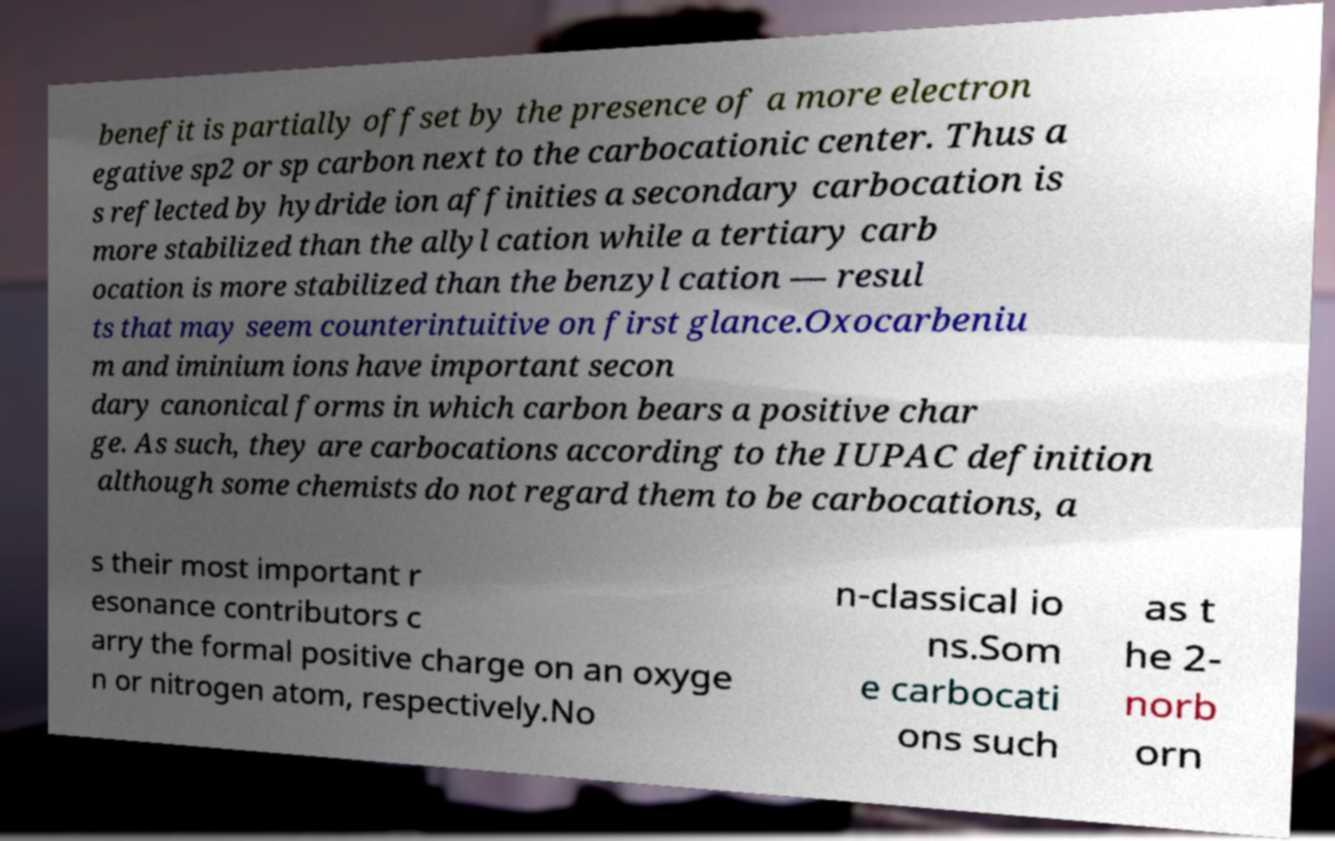I need the written content from this picture converted into text. Can you do that? benefit is partially offset by the presence of a more electron egative sp2 or sp carbon next to the carbocationic center. Thus a s reflected by hydride ion affinities a secondary carbocation is more stabilized than the allyl cation while a tertiary carb ocation is more stabilized than the benzyl cation — resul ts that may seem counterintuitive on first glance.Oxocarbeniu m and iminium ions have important secon dary canonical forms in which carbon bears a positive char ge. As such, they are carbocations according to the IUPAC definition although some chemists do not regard them to be carbocations, a s their most important r esonance contributors c arry the formal positive charge on an oxyge n or nitrogen atom, respectively.No n-classical io ns.Som e carbocati ons such as t he 2- norb orn 